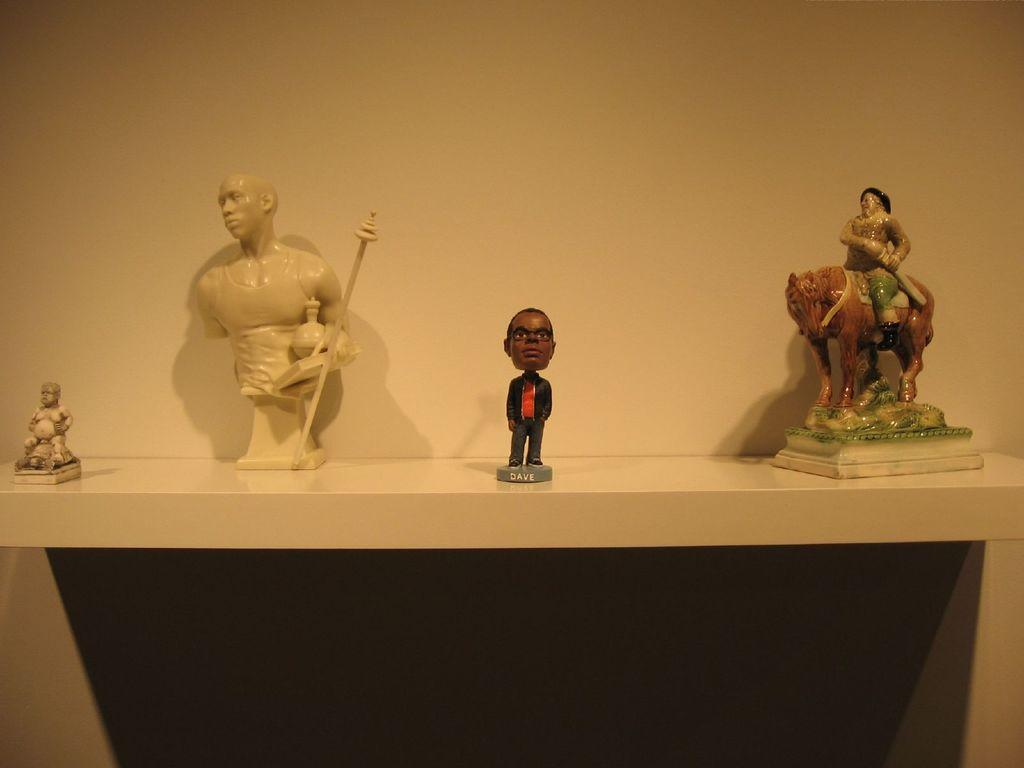What objects can be seen on the shelf in the image? There are sculptures and toys on a shelf in the image. What can be seen in the background of the image? There is a wall visible in the background of the image. How many snakes are crawling on the umbrellas in the image? There are no snakes or umbrellas present in the image. 